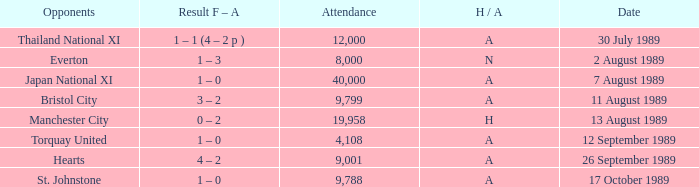When did Manchester United play against Bristol City with an H/A of A? 11 August 1989. 